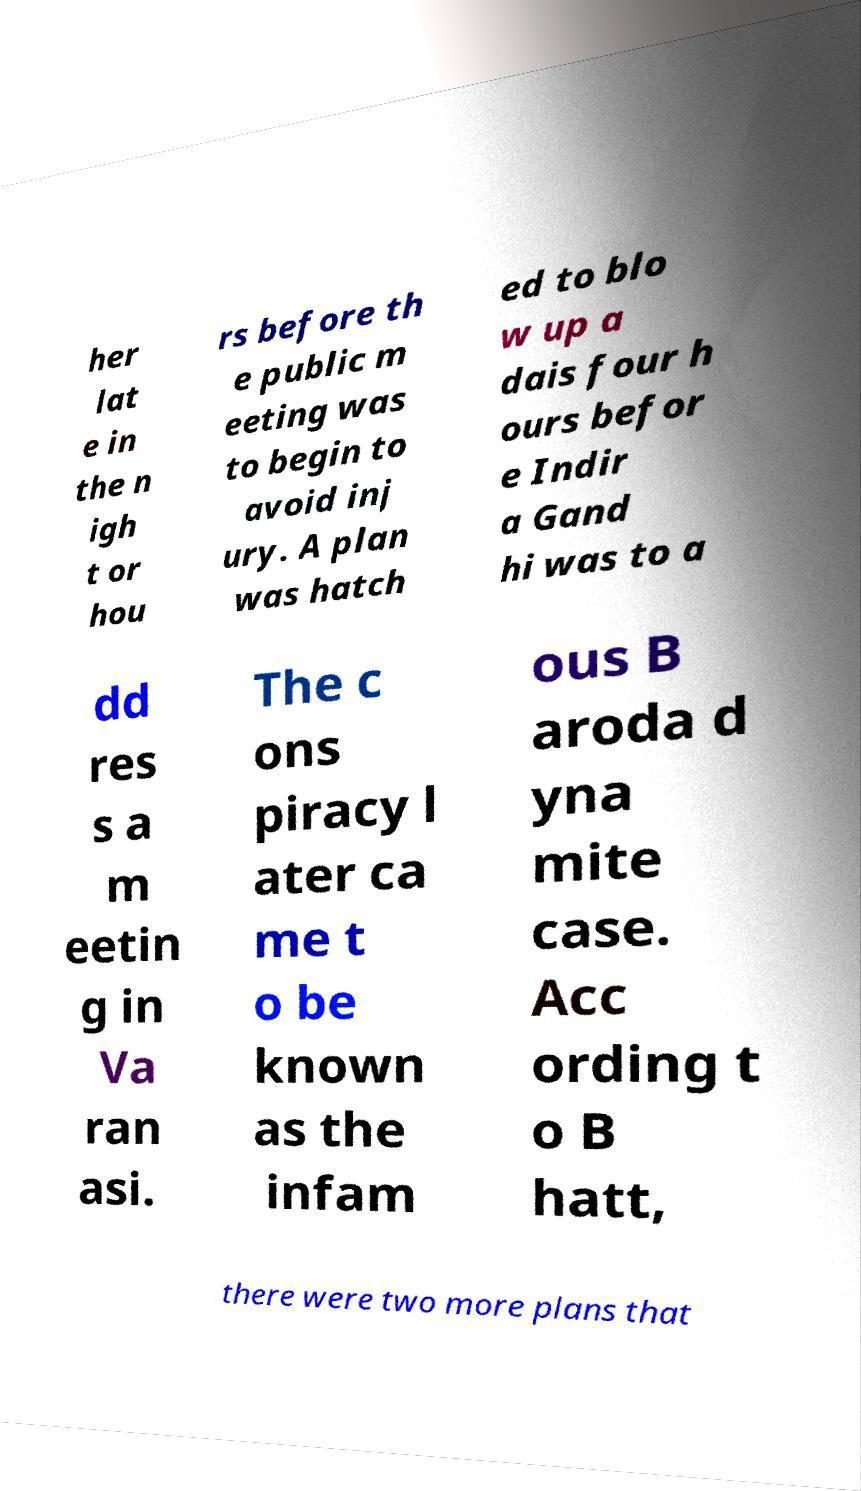Can you accurately transcribe the text from the provided image for me? her lat e in the n igh t or hou rs before th e public m eeting was to begin to avoid inj ury. A plan was hatch ed to blo w up a dais four h ours befor e Indir a Gand hi was to a dd res s a m eetin g in Va ran asi. The c ons piracy l ater ca me t o be known as the infam ous B aroda d yna mite case. Acc ording t o B hatt, there were two more plans that 